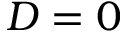<formula> <loc_0><loc_0><loc_500><loc_500>D = 0</formula> 